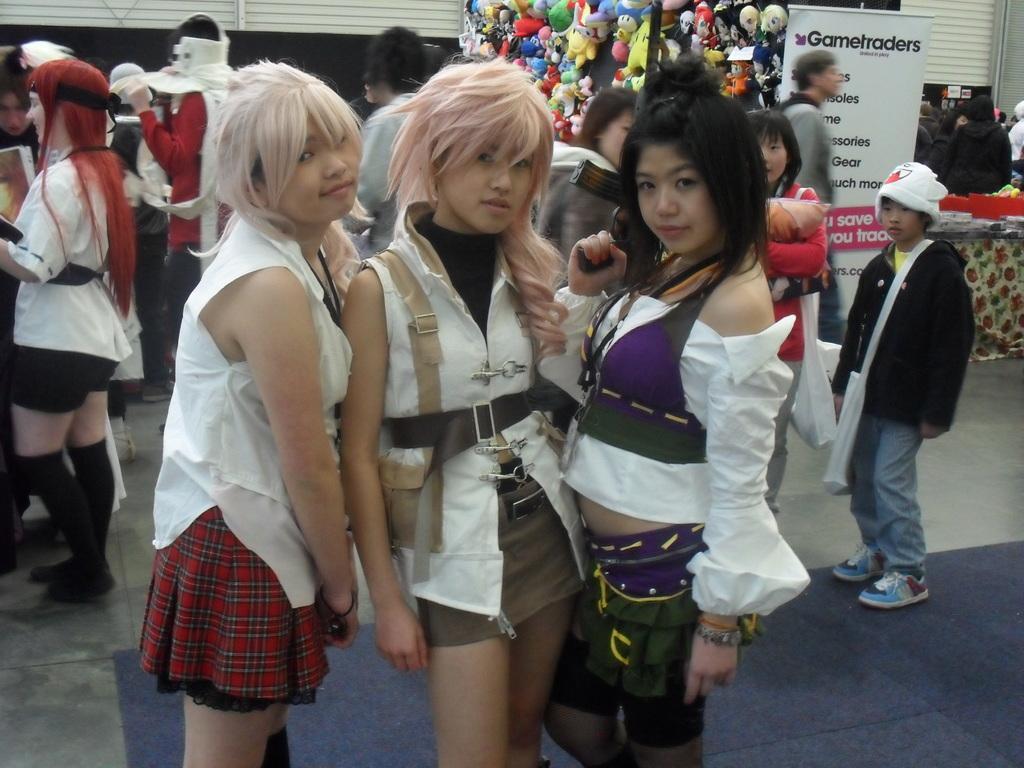Could you give a brief overview of what you see in this image? In this image I can see the group of people with different color dresses. In the background I can see the banner, few more people, many colorful dolls and some objects on the table. I can also see the rolling shutters in the back. 